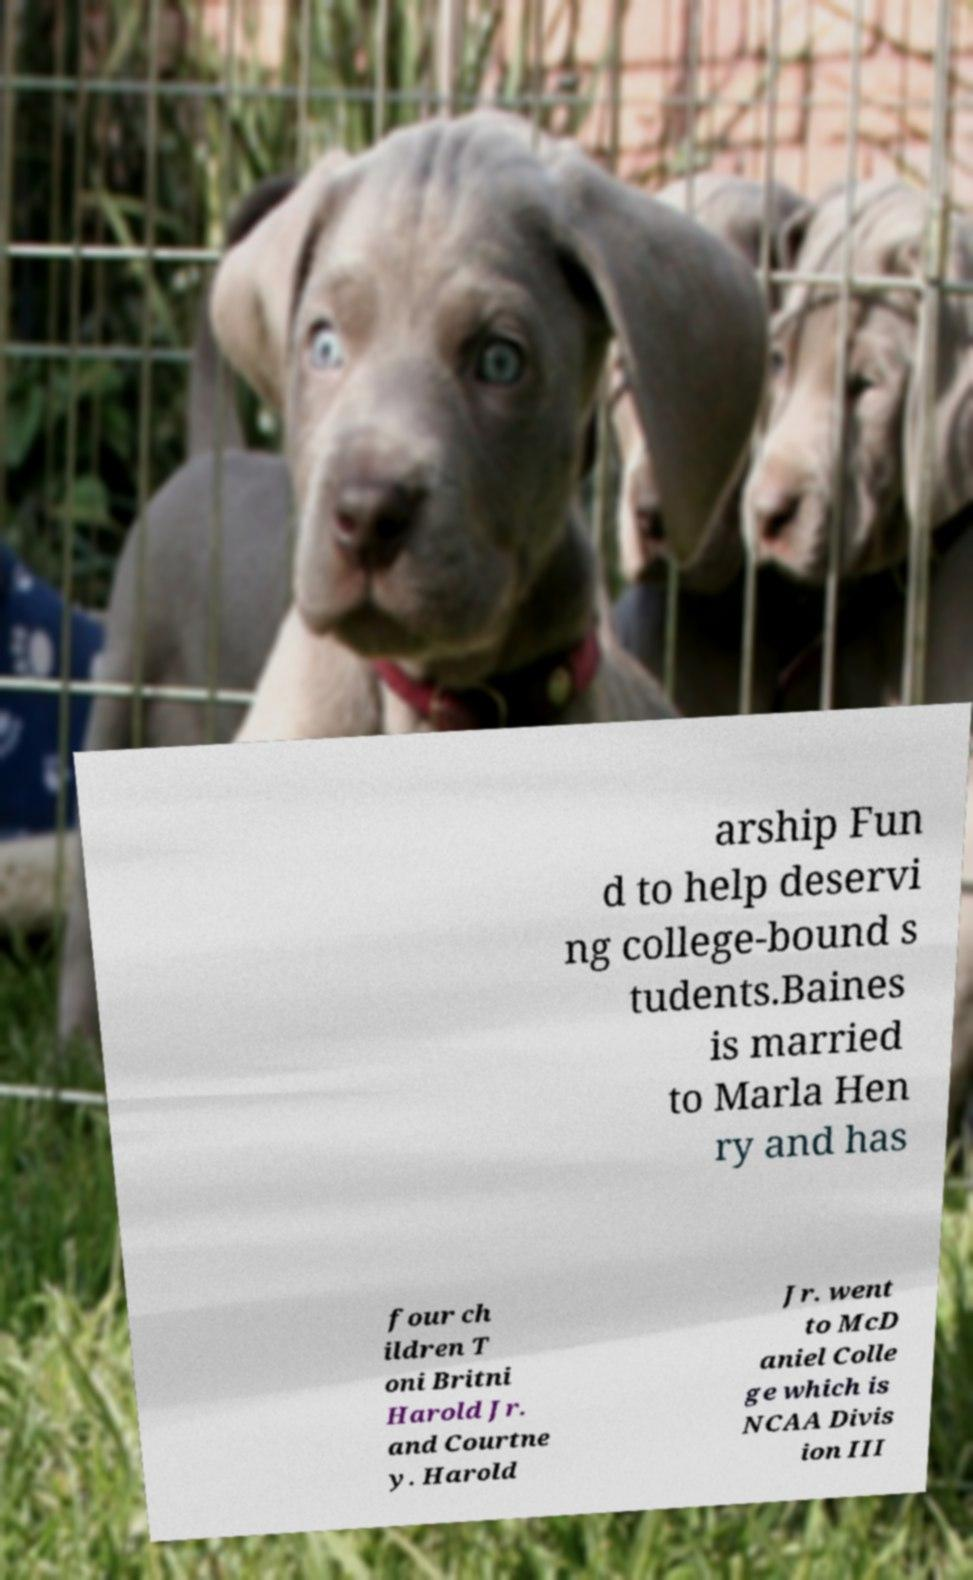Can you read and provide the text displayed in the image?This photo seems to have some interesting text. Can you extract and type it out for me? arship Fun d to help deservi ng college-bound s tudents.Baines is married to Marla Hen ry and has four ch ildren T oni Britni Harold Jr. and Courtne y. Harold Jr. went to McD aniel Colle ge which is NCAA Divis ion III 